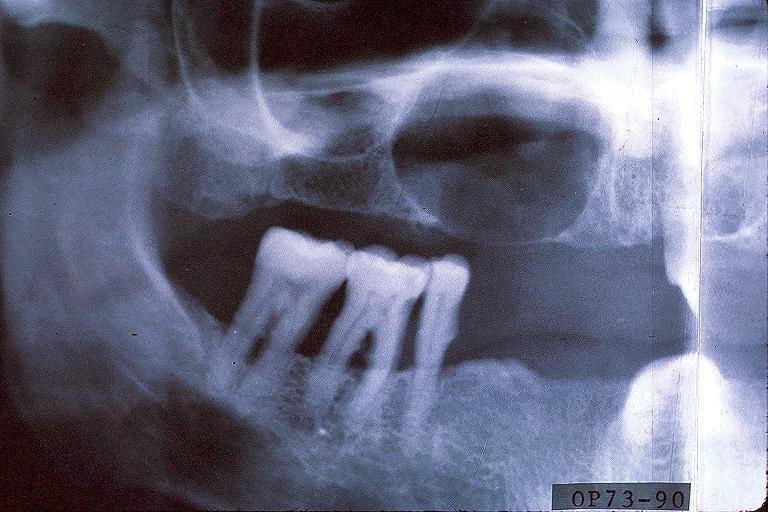s omphalocele present?
Answer the question using a single word or phrase. No 